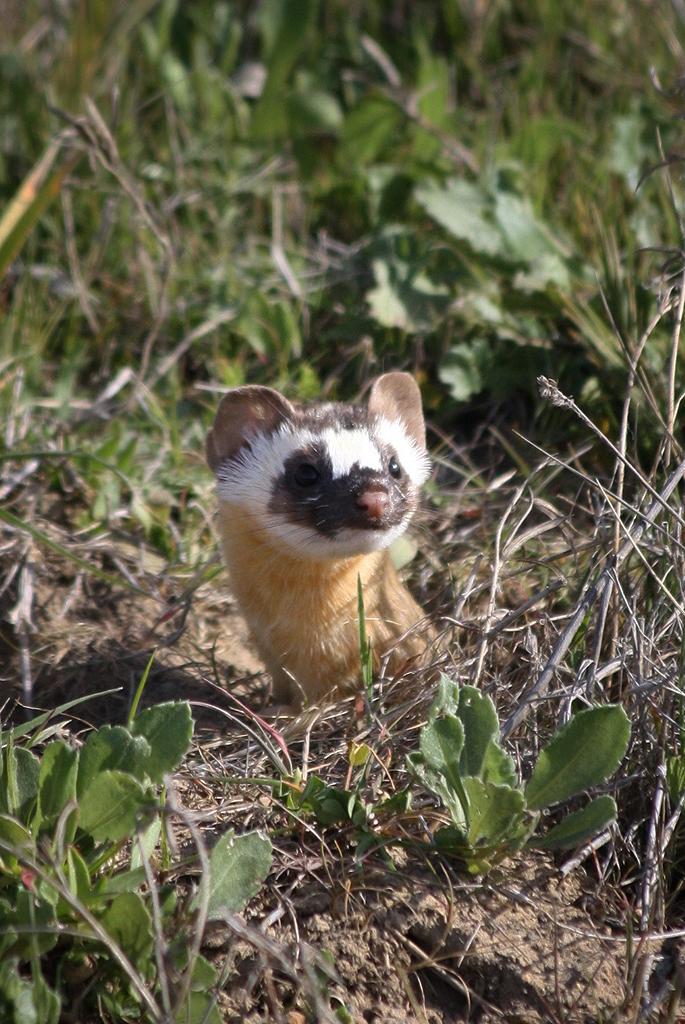In one or two sentences, can you explain what this image depicts? In this image I can see an animal on the ground and grass. This image is taken may be during a day. 